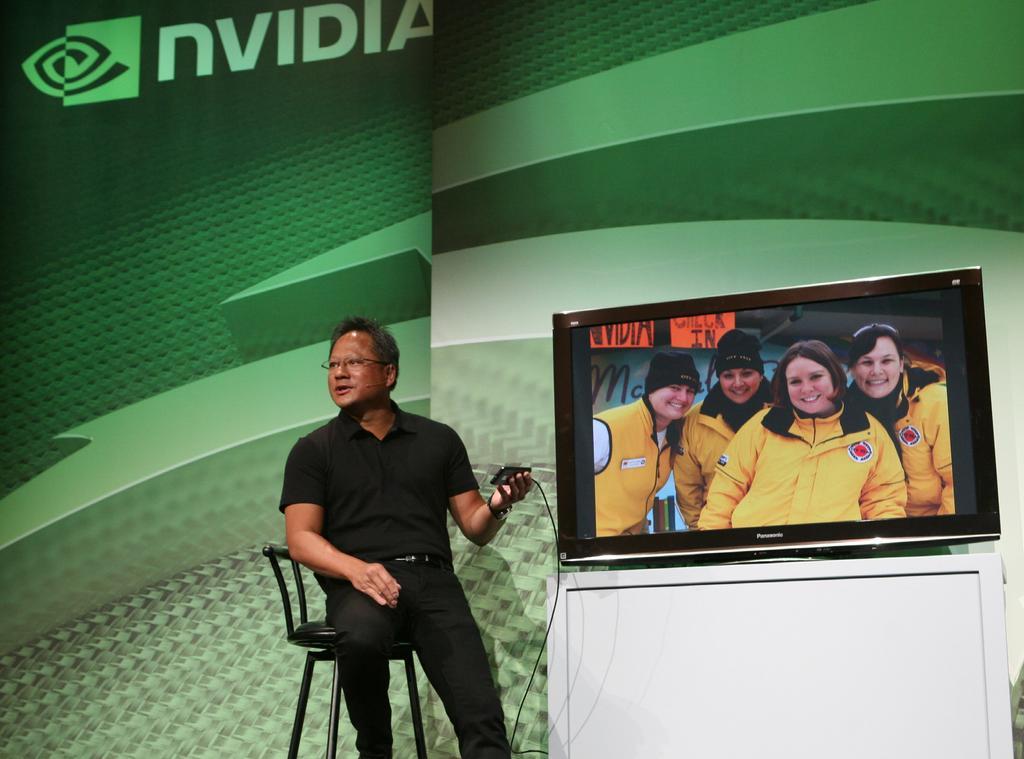Please provide a concise description of this image. In this image man sitting on a chair in the center holding a object in his hand. At the right side on white colour table there is a TV which is running and on the screen of the TV there are four persons wearing a yellow colour jacket and having smile on their faces. In the background there is a green colour sheet where we can read nvidia. 